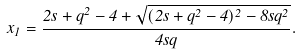Convert formula to latex. <formula><loc_0><loc_0><loc_500><loc_500>x _ { 1 } = \frac { 2 s + q ^ { 2 } - 4 + \sqrt { ( 2 s + q ^ { 2 } - 4 ) ^ { 2 } - 8 s q ^ { 2 } } } { 4 s q } .</formula> 